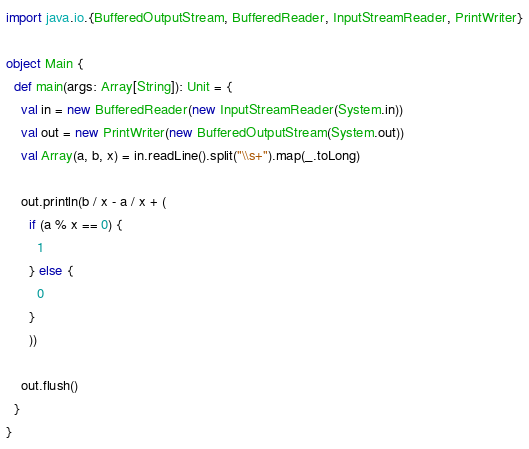Convert code to text. <code><loc_0><loc_0><loc_500><loc_500><_Scala_>import java.io.{BufferedOutputStream, BufferedReader, InputStreamReader, PrintWriter}

object Main {
  def main(args: Array[String]): Unit = {
    val in = new BufferedReader(new InputStreamReader(System.in))
    val out = new PrintWriter(new BufferedOutputStream(System.out))
    val Array(a, b, x) = in.readLine().split("\\s+").map(_.toLong)

    out.println(b / x - a / x + (
      if (a % x == 0) {
        1
      } else {
        0
      }
      ))

    out.flush()
  }
}
</code> 